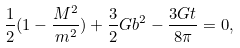<formula> <loc_0><loc_0><loc_500><loc_500>\frac { 1 } { 2 } ( 1 - \frac { M ^ { 2 } } { m ^ { 2 } } ) + \frac { 3 } { 2 } G b ^ { 2 } - \frac { 3 G t } { 8 \pi } = 0 ,</formula> 